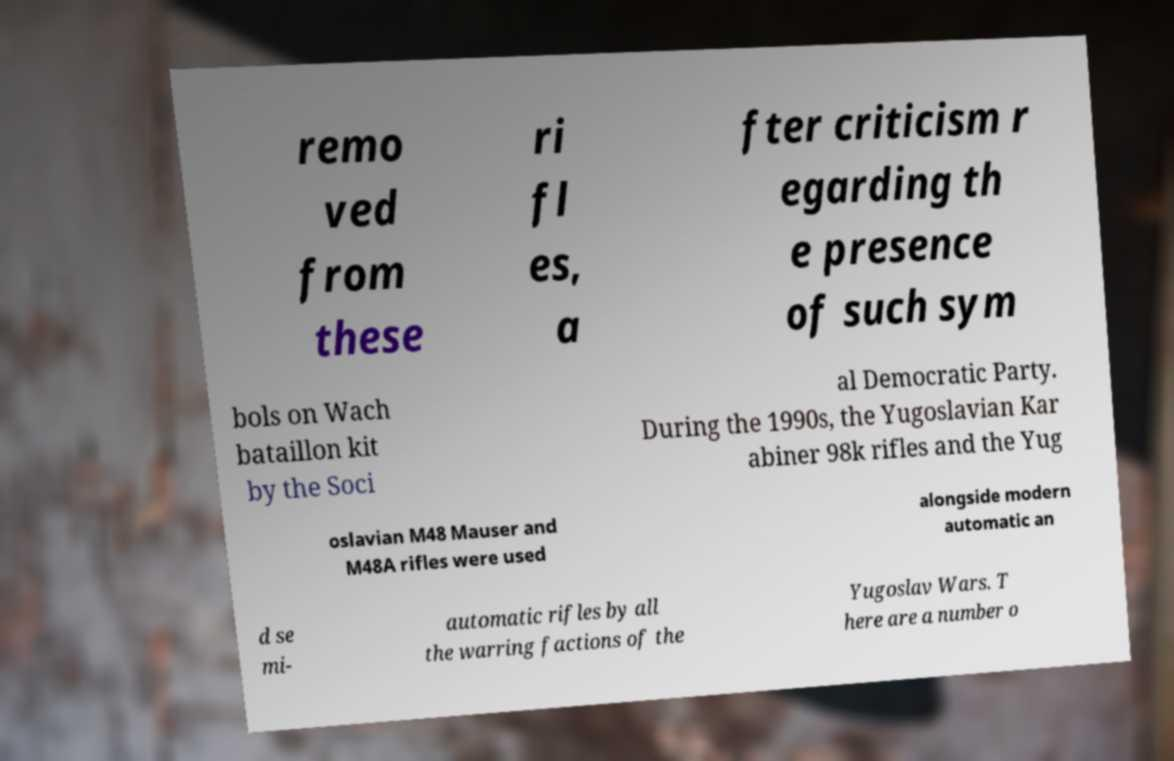Please read and relay the text visible in this image. What does it say? remo ved from these ri fl es, a fter criticism r egarding th e presence of such sym bols on Wach bataillon kit by the Soci al Democratic Party. During the 1990s, the Yugoslavian Kar abiner 98k rifles and the Yug oslavian M48 Mauser and M48A rifles were used alongside modern automatic an d se mi- automatic rifles by all the warring factions of the Yugoslav Wars. T here are a number o 